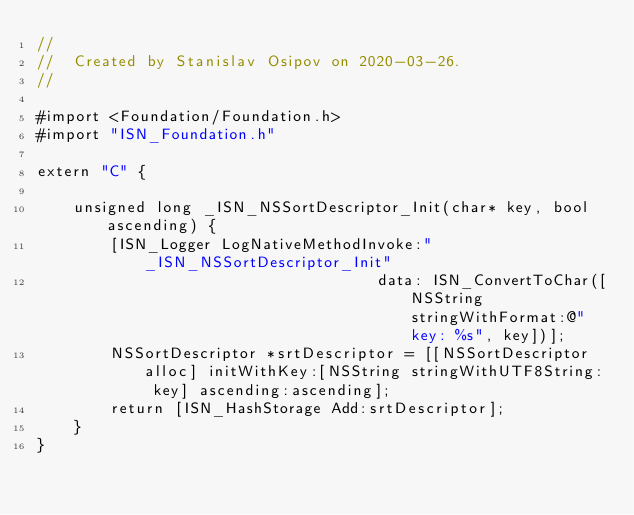Convert code to text. <code><loc_0><loc_0><loc_500><loc_500><_ObjectiveC_>//
//  Created by Stanislav Osipov on 2020-03-26.
//

#import <Foundation/Foundation.h>
#import "ISN_Foundation.h"

extern "C" {

    unsigned long _ISN_NSSortDescriptor_Init(char* key, bool ascending) {
        [ISN_Logger LogNativeMethodInvoke:"_ISN_NSSortDescriptor_Init"
                                     data: ISN_ConvertToChar([NSString stringWithFormat:@"key: %s", key])];
        NSSortDescriptor *srtDescriptor = [[NSSortDescriptor alloc] initWithKey:[NSString stringWithUTF8String: key] ascending:ascending];
        return [ISN_HashStorage Add:srtDescriptor];
    }
}
</code> 